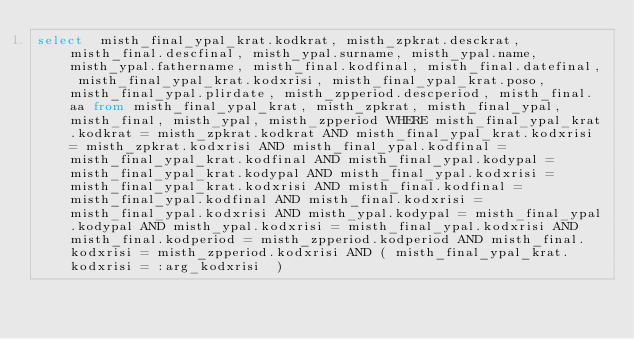<code> <loc_0><loc_0><loc_500><loc_500><_SQL_>select  misth_final_ypal_krat.kodkrat, misth_zpkrat.desckrat, misth_final.descfinal, misth_ypal.surname, misth_ypal.name, misth_ypal.fathername, misth_final.kodfinal, misth_final.datefinal, misth_final_ypal_krat.kodxrisi, misth_final_ypal_krat.poso, misth_final_ypal.plirdate, misth_zpperiod.descperiod, misth_final.aa from misth_final_ypal_krat, misth_zpkrat, misth_final_ypal, misth_final, misth_ypal, misth_zpperiod WHERE misth_final_ypal_krat.kodkrat = misth_zpkrat.kodkrat AND misth_final_ypal_krat.kodxrisi = misth_zpkrat.kodxrisi AND misth_final_ypal.kodfinal = misth_final_ypal_krat.kodfinal AND misth_final_ypal.kodypal = misth_final_ypal_krat.kodypal AND misth_final_ypal.kodxrisi = misth_final_ypal_krat.kodxrisi AND misth_final.kodfinal = misth_final_ypal.kodfinal AND misth_final.kodxrisi = misth_final_ypal.kodxrisi AND misth_ypal.kodypal = misth_final_ypal.kodypal AND misth_ypal.kodxrisi = misth_final_ypal.kodxrisi AND misth_final.kodperiod = misth_zpperiod.kodperiod AND misth_final.kodxrisi = misth_zpperiod.kodxrisi AND ( misth_final_ypal_krat.kodxrisi = :arg_kodxrisi  ) </code> 